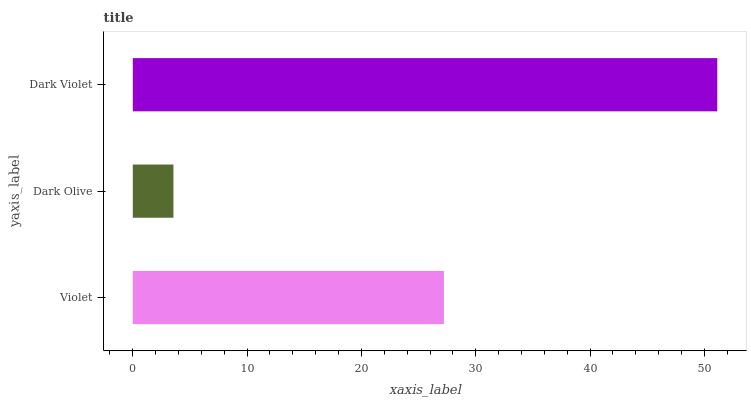Is Dark Olive the minimum?
Answer yes or no. Yes. Is Dark Violet the maximum?
Answer yes or no. Yes. Is Dark Violet the minimum?
Answer yes or no. No. Is Dark Olive the maximum?
Answer yes or no. No. Is Dark Violet greater than Dark Olive?
Answer yes or no. Yes. Is Dark Olive less than Dark Violet?
Answer yes or no. Yes. Is Dark Olive greater than Dark Violet?
Answer yes or no. No. Is Dark Violet less than Dark Olive?
Answer yes or no. No. Is Violet the high median?
Answer yes or no. Yes. Is Violet the low median?
Answer yes or no. Yes. Is Dark Olive the high median?
Answer yes or no. No. Is Dark Olive the low median?
Answer yes or no. No. 